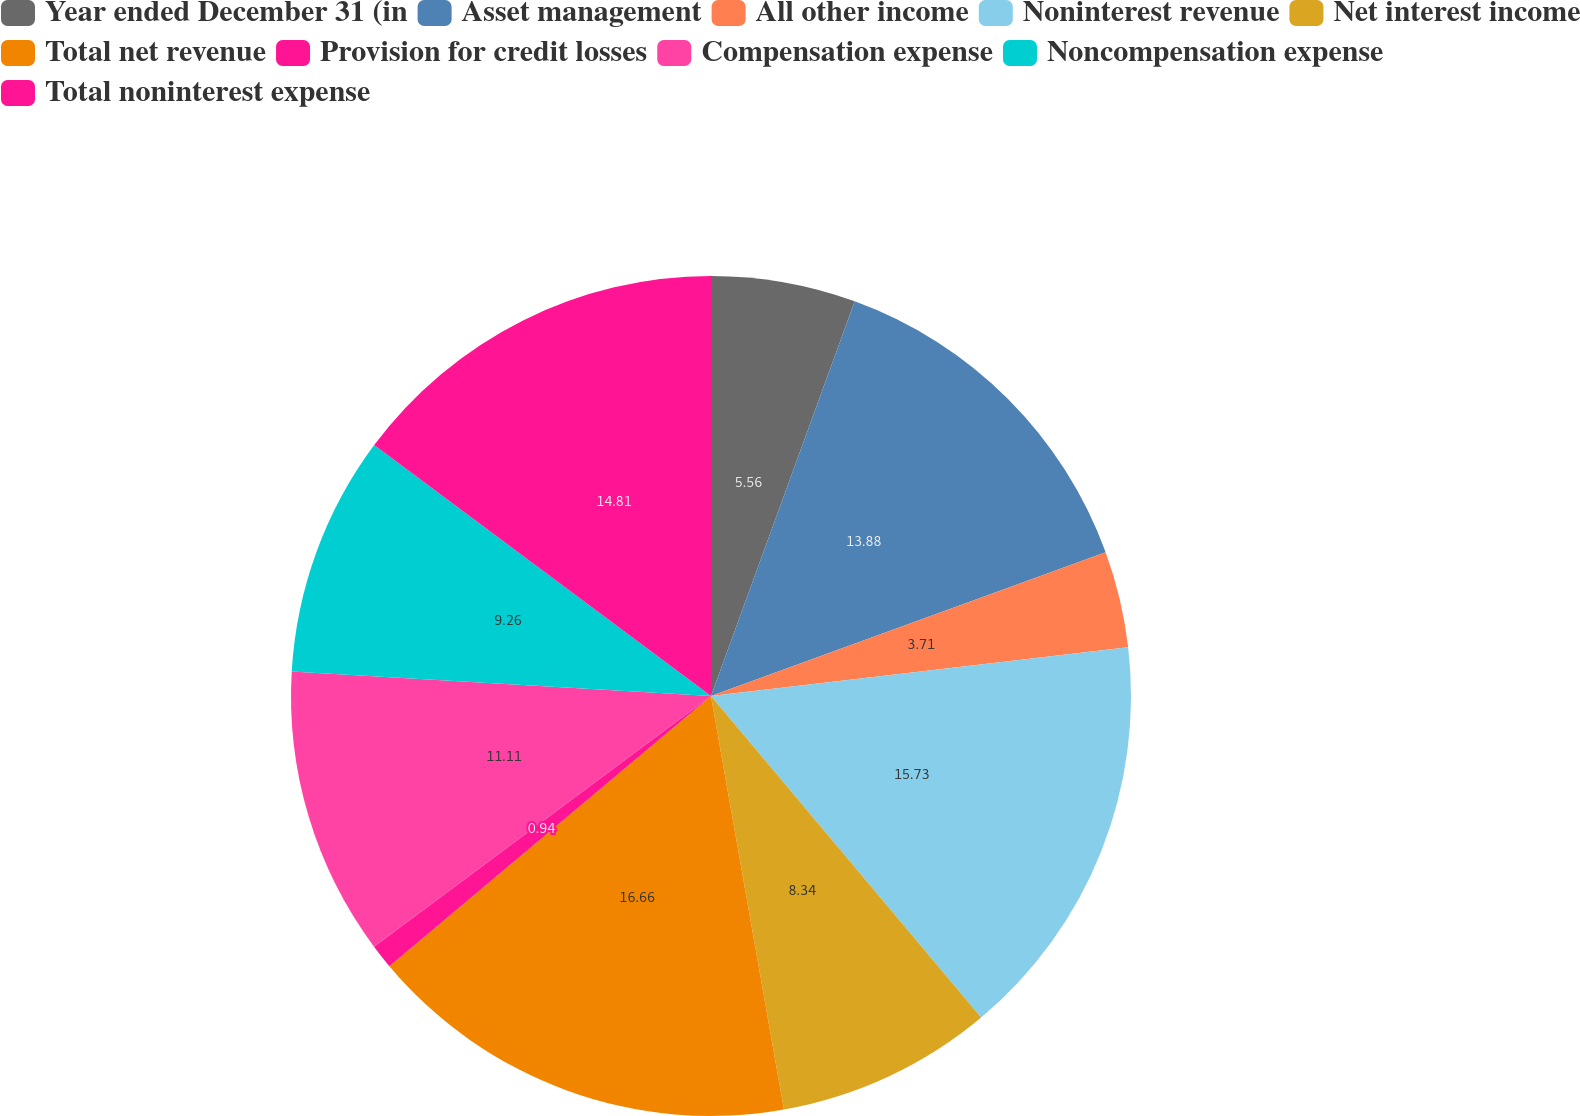<chart> <loc_0><loc_0><loc_500><loc_500><pie_chart><fcel>Year ended December 31 (in<fcel>Asset management<fcel>All other income<fcel>Noninterest revenue<fcel>Net interest income<fcel>Total net revenue<fcel>Provision for credit losses<fcel>Compensation expense<fcel>Noncompensation expense<fcel>Total noninterest expense<nl><fcel>5.56%<fcel>13.88%<fcel>3.71%<fcel>15.73%<fcel>8.34%<fcel>16.66%<fcel>0.94%<fcel>11.11%<fcel>9.26%<fcel>14.81%<nl></chart> 